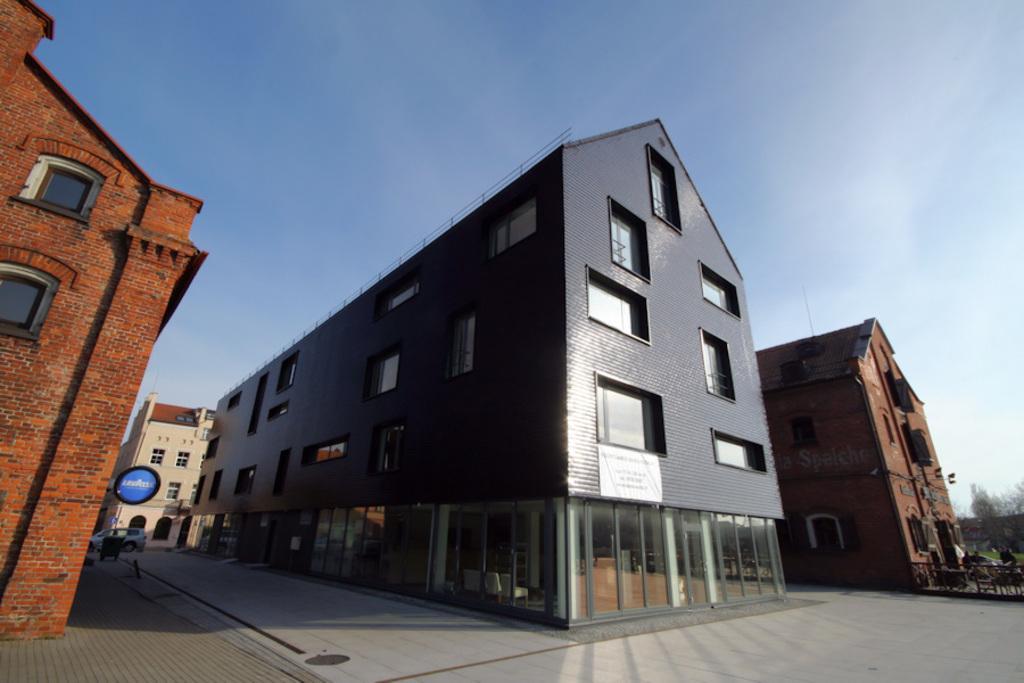Could you give a brief overview of what you see in this image? In this image we can see some buildings with windows. We can also see a signboard, car, a fence, trees and the sky which looks cloudy. 